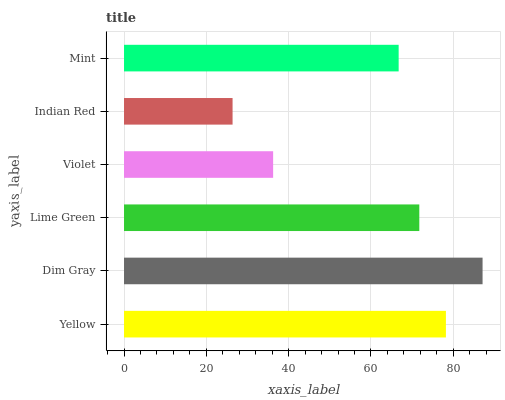Is Indian Red the minimum?
Answer yes or no. Yes. Is Dim Gray the maximum?
Answer yes or no. Yes. Is Lime Green the minimum?
Answer yes or no. No. Is Lime Green the maximum?
Answer yes or no. No. Is Dim Gray greater than Lime Green?
Answer yes or no. Yes. Is Lime Green less than Dim Gray?
Answer yes or no. Yes. Is Lime Green greater than Dim Gray?
Answer yes or no. No. Is Dim Gray less than Lime Green?
Answer yes or no. No. Is Lime Green the high median?
Answer yes or no. Yes. Is Mint the low median?
Answer yes or no. Yes. Is Violet the high median?
Answer yes or no. No. Is Violet the low median?
Answer yes or no. No. 